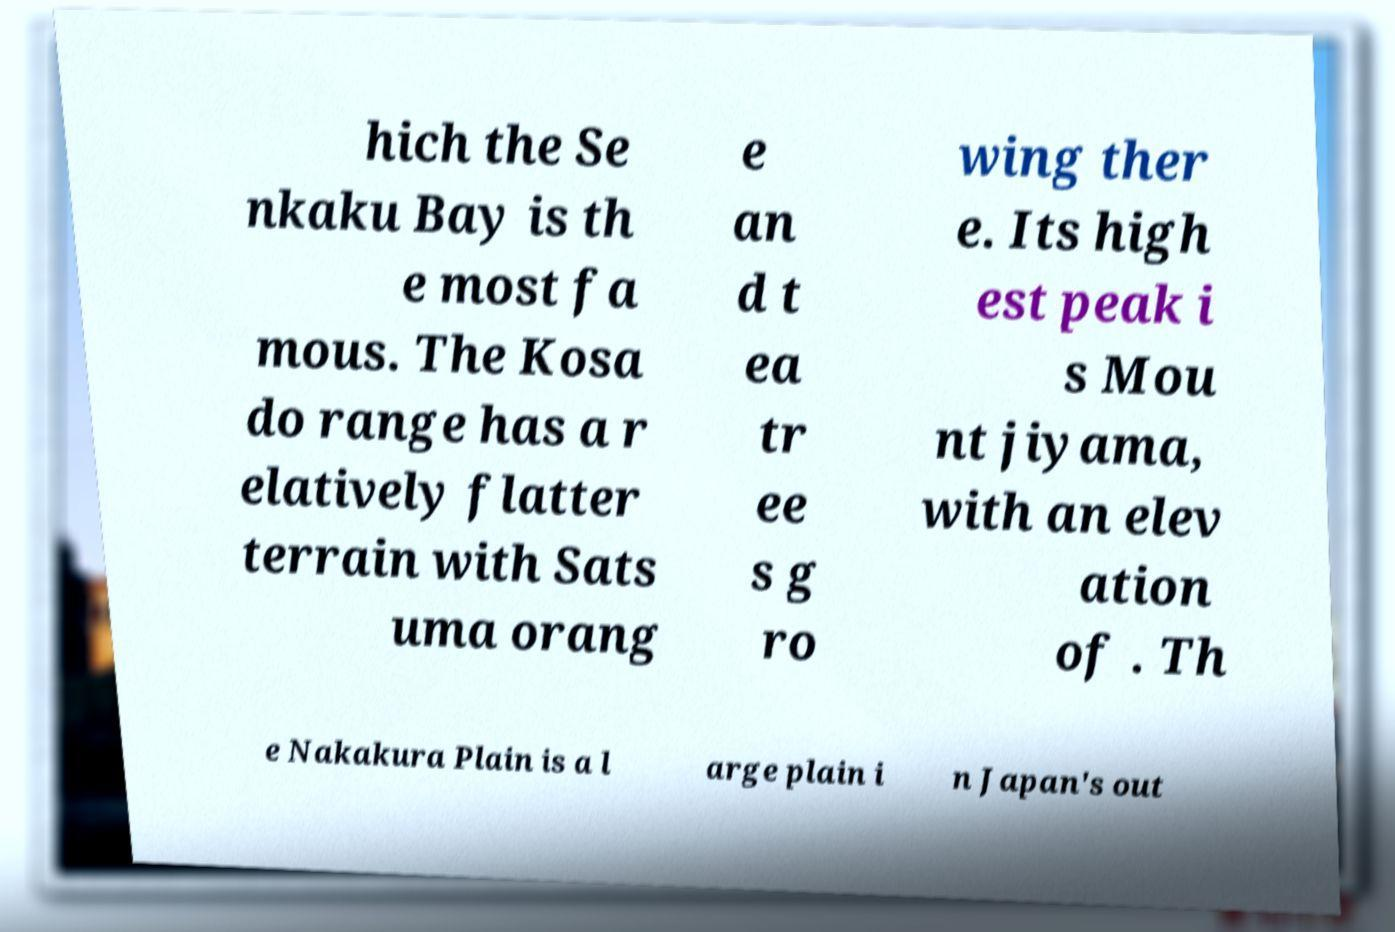Please read and relay the text visible in this image. What does it say? hich the Se nkaku Bay is th e most fa mous. The Kosa do range has a r elatively flatter terrain with Sats uma orang e an d t ea tr ee s g ro wing ther e. Its high est peak i s Mou nt jiyama, with an elev ation of . Th e Nakakura Plain is a l arge plain i n Japan's out 